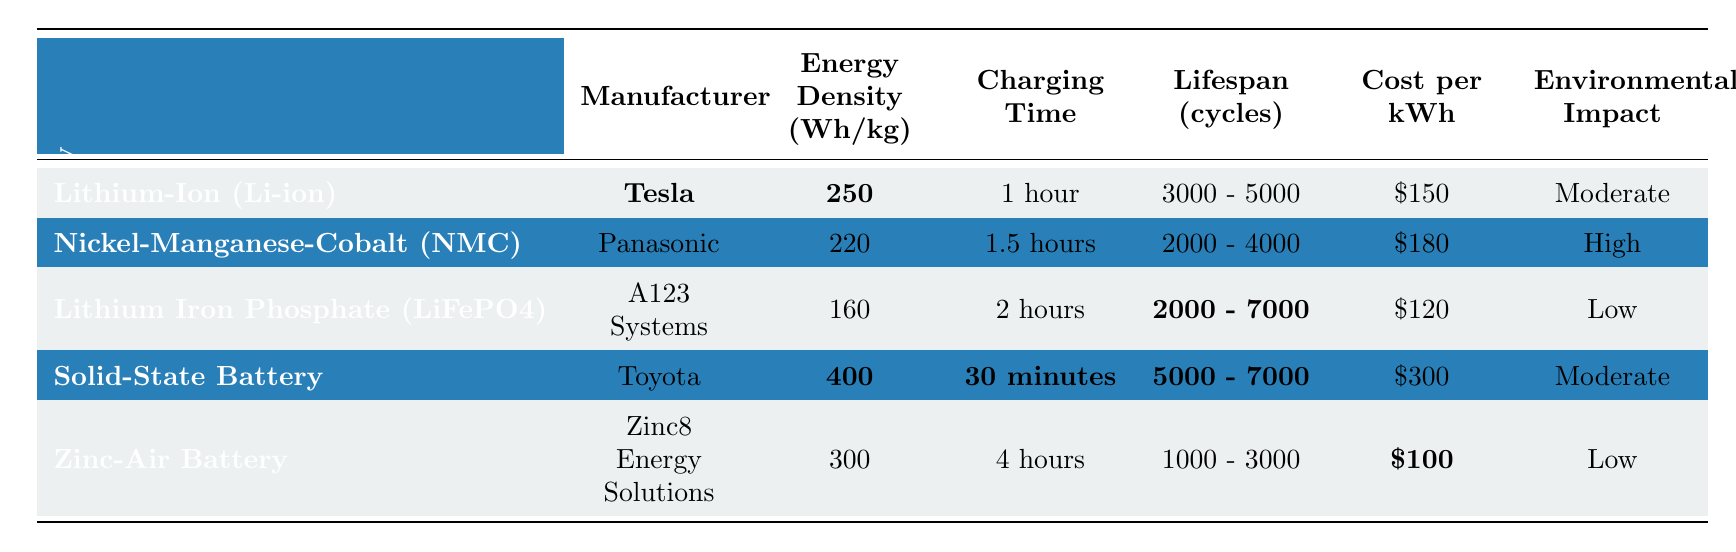What is the energy density of Lithium-Ion (Li-ion) batteries? The energy density for Lithium-Ion (Li-ion) batteries, as listed in the table, is 250 Wh/kg.
Answer: 250 Wh/kg How long does it take to charge a Solid-State Battery? The charging time for a Solid-State Battery is 30 minutes, as shown in the table.
Answer: 30 minutes Which battery technology has the lowest cost per kWh? According to the table, the Zinc-Air Battery has the lowest cost per kWh at $100.
Answer: $100 Are Nickel-Manganese-Cobalt (NMC) batteries more environmentally friendly than Lithium Iron Phosphate (LiFePO4)? No, the table indicates that NMC has a high environmental impact while LiFePO4 is classified as low impact.
Answer: No What is the lifespan range of Lithium Iron Phosphate (LiFePO4) batteries? The lifespan range for Lithium Iron Phosphate (LiFePO4) batteries is 2000 to 7000 cycles, as noted in the table.
Answer: 2000 - 7000 cycles Which battery technology has the highest energy density and what is its value? The Solid-State Battery has the highest energy density of 400 Wh/kg, according to the data in the table.
Answer: 400 Wh/kg If we average the lifespan of all the battery technologies, what is the average lifespan? First, we note the lifespan ranges: Li-ion (4000), NMC (3000), LiFePO4 (4500), Solid-State (6000), and Zinc-Air (2000). We average them by taking the midpoint of each range and then calculating: (4000 + 3000 + 4500 + 6000 + 2000) / 5 = 4000 cycles.
Answer: 4000 cycles Which manufacturer produces the Lithium Iron Phosphate (LiFePO4) battery? The table specifies that A123 Systems is the manufacturer of the Lithium Iron Phosphate (LiFePO4) battery.
Answer: A123 Systems What is the charging time difference between Nickel-Manganese-Cobalt (NMC) and Zinc-Air batteries? The charging time for NMC is 1.5 hours and for Zinc-Air is 4 hours. The difference is 4 - 1.5 = 2.5 hours.
Answer: 2.5 hours Which battery type has the longest lifespan and what is the range? The Solid-State Battery has the longest lifespan, with a range of 5000 - 7000 cycles, as per the table.
Answer: 5000 - 7000 cycles 